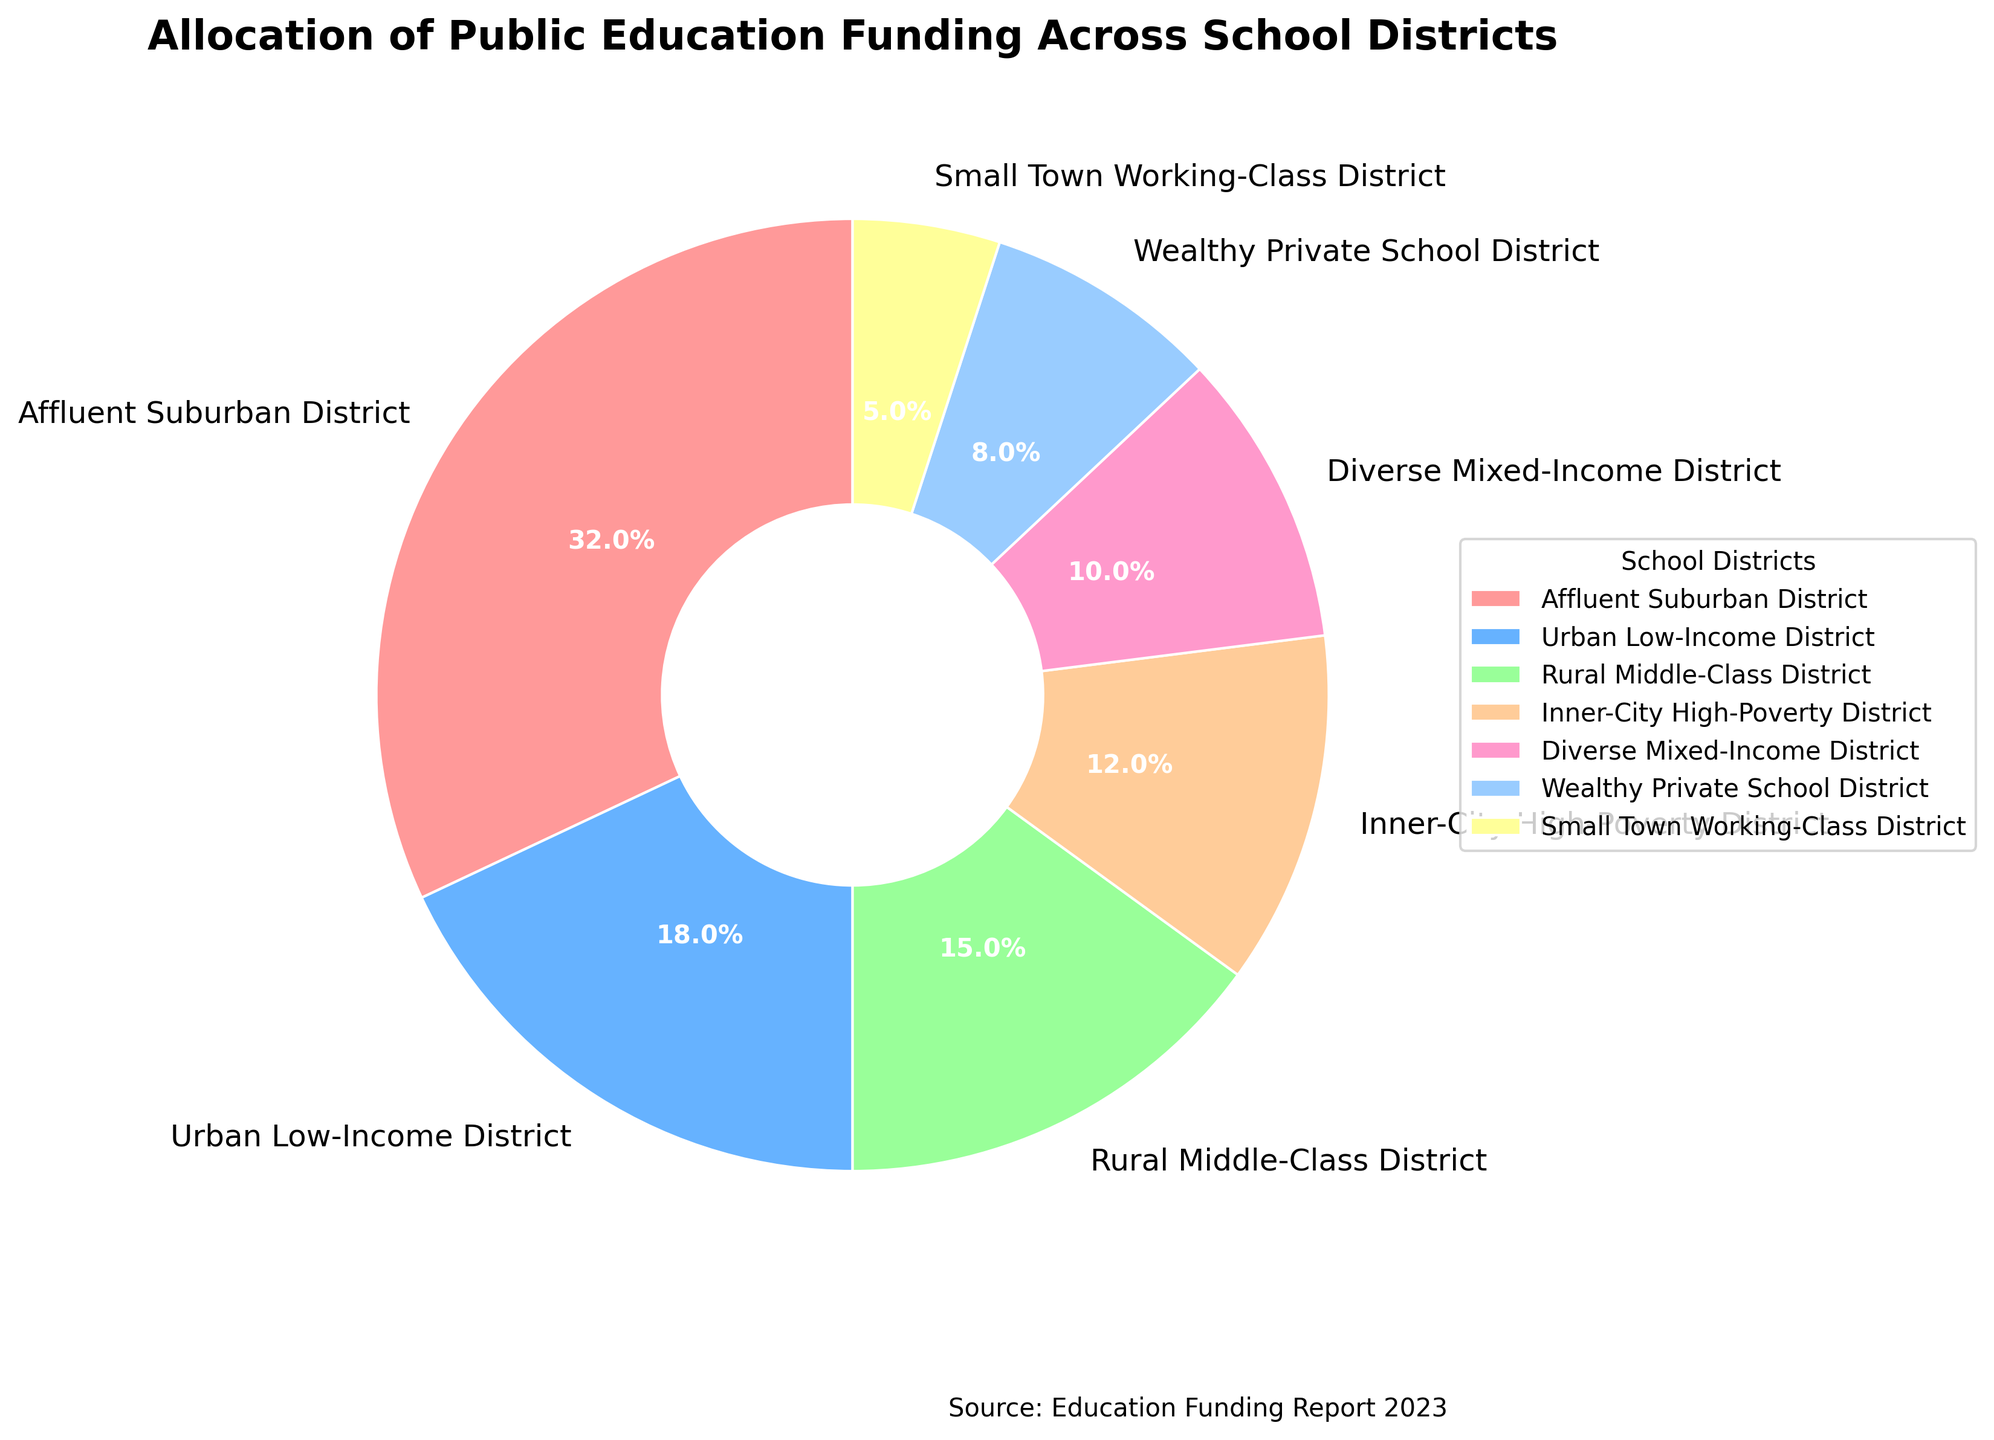What is the total percentage of funding allocated to the Affluent Suburban District and the Urban Low-Income District? The Affluent Suburban District receives 32% of the funding, and the Urban Low-Income District receives 18% of the funding. Summing these gives 32 + 18 = 50%.
Answer: 50% Which district receives more funding: the Rural Middle-Class District or the Inner-City High-Poverty District? The Rural Middle-Class District receives 15% of the funding, while the Inner-City High-Poverty District receives 12%. Comparing these values, 15% is greater than 12%.
Answer: Rural Middle-Class District How does the funding percentage for the Diverse Mixed-Income District compare to the Small Town Working-Class District? The Diverse Mixed-Income District receives 10% of the funding, and the Small Town Working-Class District receives 5% of the funding. Therefore, the Diverse Mixed-Income District receives 10 - 5 = 5% more funding.
Answer: 5% more What is the difference in funding between the district with the highest allocation and the district with the lowest allocation? The district with the highest allocation is the Affluent Suburban District with 32%, and the district with the lowest allocation is the Small Town Working-Class District with 5%. The difference is 32 - 5 = 27%.
Answer: 27% Which district corresponding to the yellow color on the chart, and what percentage of funding do they receive? On the pie chart, the yellow color represents the Diverse Mixed-Income District, which receives 10% of the funding.
Answer: Diverse Mixed-Income District, 10% What is the sum of the funding percentages for the Urban Low-Income District, Inner-City High-Poverty District, and Small Town Working-Class District? The Urban Low-Income District receives 18%, the Inner-City High-Poverty District receives 12%, and the Small Town Working-Class District receives 5%. Summing these percentages: 18 + 12 + 5 = 35%.
Answer: 35% Which district receives less than 10% of the total funding, and what is the exact percentage? The Small Town Working-Class District receives less than 10%, specifically 5% of the funding. The Wealthy Private School District also comes close but receives 8%, which is below 10%.
Answer: Small Town Working-Class District, 5% If the funding for the Wealthy Private School District were doubled, what would be the new percentage, and would it surpass the funding of the Rural Middle-Class District? Currently, the Wealthy Private School District receives 8%. If doubled, the new percentage would be 8 * 2 = 16%, which would indeed surpass the Rural Middle-Class District that receives 15%.
Answer: 16%, yes What percentage of funding do the districts labeled as "affluent" (Affluent Suburban District and Wealthy Private School District) receive combined? The Affluent Suburban District receives 32%, and the Wealthy Private School District receives 8%. Together, they receive 32 + 8 = 40% of the total funding.
Answer: 40% Which district, colored in green, receives how much funding, and how does it compare to the funding received by the Affluent Suburban District? The green color represents the Rural Middle-Class District, which receives 15% of the funding. This is 32% - 15% = 17% less than the funding received by the Affluent Suburban District, which receives 32%.
Answer: Rural Middle-Class District, 17% less 